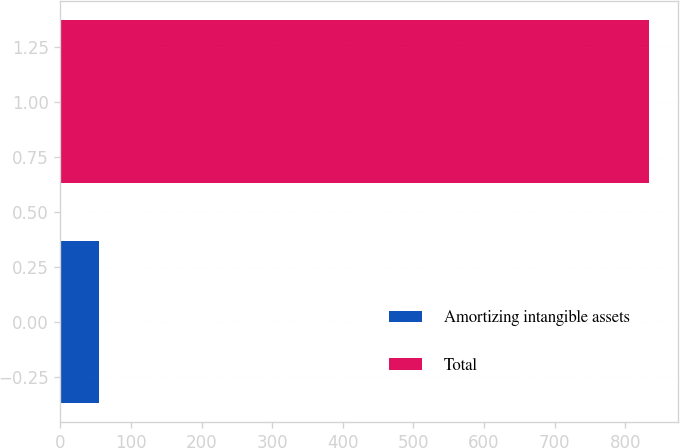<chart> <loc_0><loc_0><loc_500><loc_500><bar_chart><fcel>Amortizing intangible assets<fcel>Total<nl><fcel>55.2<fcel>833.5<nl></chart> 